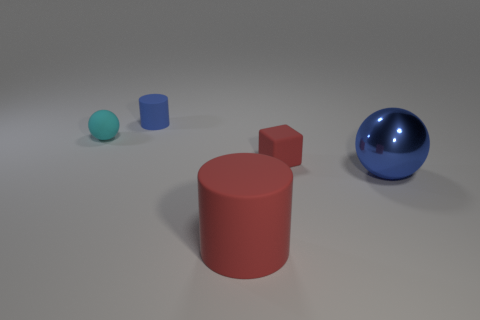Add 1 small red objects. How many objects exist? 6 Subtract all blocks. How many objects are left? 4 Subtract all big red rubber things. Subtract all tiny yellow metallic objects. How many objects are left? 4 Add 3 matte balls. How many matte balls are left? 4 Add 5 big spheres. How many big spheres exist? 6 Subtract 0 brown balls. How many objects are left? 5 